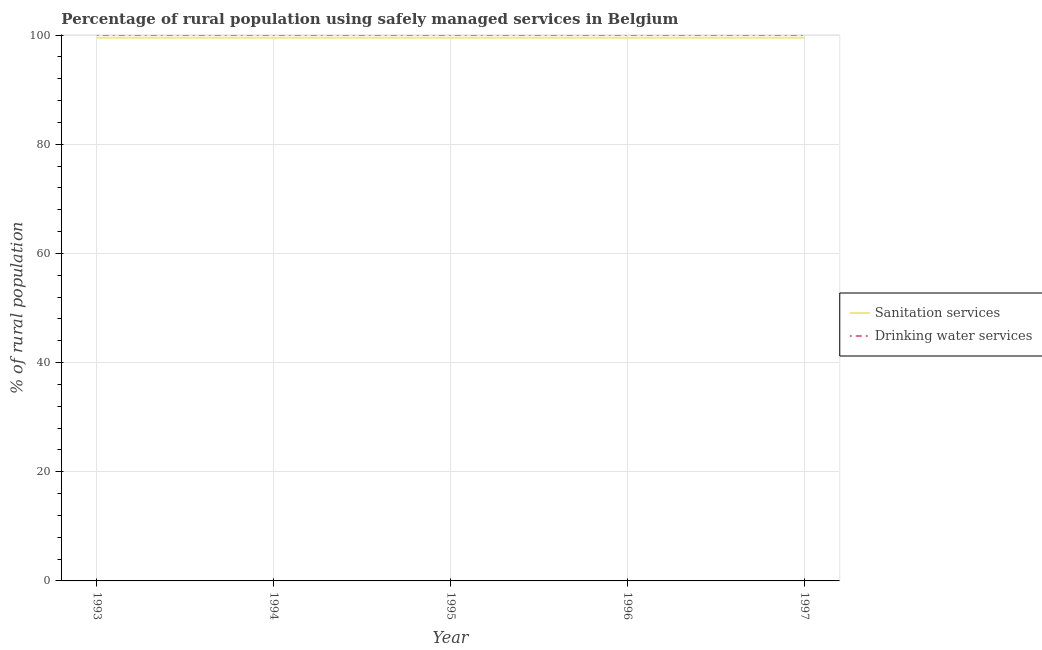Does the line corresponding to percentage of rural population who used sanitation services intersect with the line corresponding to percentage of rural population who used drinking water services?
Your response must be concise. No. What is the percentage of rural population who used sanitation services in 1995?
Keep it short and to the point. 99.5. Across all years, what is the maximum percentage of rural population who used sanitation services?
Offer a very short reply. 99.5. Across all years, what is the minimum percentage of rural population who used drinking water services?
Ensure brevity in your answer.  100. In which year was the percentage of rural population who used sanitation services minimum?
Your answer should be very brief. 1993. What is the total percentage of rural population who used sanitation services in the graph?
Offer a very short reply. 497.5. What is the average percentage of rural population who used drinking water services per year?
Your response must be concise. 100. In the year 1993, what is the difference between the percentage of rural population who used sanitation services and percentage of rural population who used drinking water services?
Keep it short and to the point. -0.5. In how many years, is the percentage of rural population who used sanitation services greater than 4 %?
Your answer should be very brief. 5. What is the ratio of the percentage of rural population who used drinking water services in 1994 to that in 1997?
Offer a very short reply. 1. Is the difference between the percentage of rural population who used drinking water services in 1993 and 1996 greater than the difference between the percentage of rural population who used sanitation services in 1993 and 1996?
Your response must be concise. No. In how many years, is the percentage of rural population who used drinking water services greater than the average percentage of rural population who used drinking water services taken over all years?
Your response must be concise. 0. Is the percentage of rural population who used drinking water services strictly less than the percentage of rural population who used sanitation services over the years?
Make the answer very short. No. How many lines are there?
Offer a very short reply. 2. How many years are there in the graph?
Give a very brief answer. 5. Where does the legend appear in the graph?
Offer a very short reply. Center right. How many legend labels are there?
Your answer should be very brief. 2. What is the title of the graph?
Keep it short and to the point. Percentage of rural population using safely managed services in Belgium. Does "Commercial bank branches" appear as one of the legend labels in the graph?
Your answer should be compact. No. What is the label or title of the X-axis?
Provide a short and direct response. Year. What is the label or title of the Y-axis?
Keep it short and to the point. % of rural population. What is the % of rural population of Sanitation services in 1993?
Your answer should be very brief. 99.5. What is the % of rural population in Drinking water services in 1993?
Keep it short and to the point. 100. What is the % of rural population in Sanitation services in 1994?
Make the answer very short. 99.5. What is the % of rural population of Sanitation services in 1995?
Give a very brief answer. 99.5. What is the % of rural population in Drinking water services in 1995?
Provide a short and direct response. 100. What is the % of rural population in Sanitation services in 1996?
Your answer should be compact. 99.5. What is the % of rural population in Sanitation services in 1997?
Ensure brevity in your answer.  99.5. What is the % of rural population in Drinking water services in 1997?
Ensure brevity in your answer.  100. Across all years, what is the maximum % of rural population of Sanitation services?
Give a very brief answer. 99.5. Across all years, what is the minimum % of rural population of Sanitation services?
Ensure brevity in your answer.  99.5. What is the total % of rural population of Sanitation services in the graph?
Offer a very short reply. 497.5. What is the total % of rural population of Drinking water services in the graph?
Your response must be concise. 500. What is the difference between the % of rural population in Drinking water services in 1993 and that in 1994?
Offer a terse response. 0. What is the difference between the % of rural population in Sanitation services in 1993 and that in 1995?
Your response must be concise. 0. What is the difference between the % of rural population of Drinking water services in 1993 and that in 1995?
Keep it short and to the point. 0. What is the difference between the % of rural population in Sanitation services in 1993 and that in 1996?
Give a very brief answer. 0. What is the difference between the % of rural population in Drinking water services in 1993 and that in 1996?
Provide a short and direct response. 0. What is the difference between the % of rural population of Drinking water services in 1993 and that in 1997?
Provide a succinct answer. 0. What is the difference between the % of rural population in Sanitation services in 1994 and that in 1995?
Offer a terse response. 0. What is the difference between the % of rural population in Drinking water services in 1994 and that in 1995?
Provide a short and direct response. 0. What is the difference between the % of rural population of Sanitation services in 1994 and that in 1996?
Provide a short and direct response. 0. What is the difference between the % of rural population of Drinking water services in 1994 and that in 1996?
Your answer should be very brief. 0. What is the difference between the % of rural population of Sanitation services in 1994 and that in 1997?
Offer a terse response. 0. What is the difference between the % of rural population in Sanitation services in 1995 and that in 1997?
Provide a succinct answer. 0. What is the difference between the % of rural population in Sanitation services in 1996 and that in 1997?
Your response must be concise. 0. What is the difference between the % of rural population of Drinking water services in 1996 and that in 1997?
Your answer should be very brief. 0. What is the difference between the % of rural population of Sanitation services in 1993 and the % of rural population of Drinking water services in 1997?
Keep it short and to the point. -0.5. What is the difference between the % of rural population in Sanitation services in 1994 and the % of rural population in Drinking water services in 1996?
Your answer should be compact. -0.5. What is the difference between the % of rural population in Sanitation services in 1994 and the % of rural population in Drinking water services in 1997?
Your answer should be compact. -0.5. What is the average % of rural population of Sanitation services per year?
Your response must be concise. 99.5. In the year 1994, what is the difference between the % of rural population of Sanitation services and % of rural population of Drinking water services?
Offer a terse response. -0.5. In the year 1995, what is the difference between the % of rural population in Sanitation services and % of rural population in Drinking water services?
Provide a short and direct response. -0.5. In the year 1996, what is the difference between the % of rural population in Sanitation services and % of rural population in Drinking water services?
Offer a very short reply. -0.5. In the year 1997, what is the difference between the % of rural population of Sanitation services and % of rural population of Drinking water services?
Offer a terse response. -0.5. What is the ratio of the % of rural population of Drinking water services in 1993 to that in 1995?
Provide a short and direct response. 1. What is the ratio of the % of rural population of Sanitation services in 1993 to that in 1996?
Ensure brevity in your answer.  1. What is the ratio of the % of rural population of Sanitation services in 1993 to that in 1997?
Give a very brief answer. 1. What is the ratio of the % of rural population of Drinking water services in 1995 to that in 1996?
Offer a very short reply. 1. What is the ratio of the % of rural population of Drinking water services in 1995 to that in 1997?
Provide a succinct answer. 1. What is the ratio of the % of rural population in Sanitation services in 1996 to that in 1997?
Your answer should be very brief. 1. What is the difference between the highest and the second highest % of rural population in Sanitation services?
Offer a very short reply. 0. What is the difference between the highest and the lowest % of rural population in Sanitation services?
Offer a terse response. 0. What is the difference between the highest and the lowest % of rural population in Drinking water services?
Offer a very short reply. 0. 